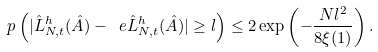Convert formula to latex. <formula><loc_0><loc_0><loc_500><loc_500>\ p \left ( | { \hat { L } } _ { N , t } ^ { h } ( \hat { A } ) - \ e { \hat { L } } _ { N , t } ^ { h } ( \hat { A } ) | \geq l \right ) \leq 2 \exp \left ( - \frac { N l ^ { 2 } } { 8 \xi ( 1 ) } \right ) .</formula> 